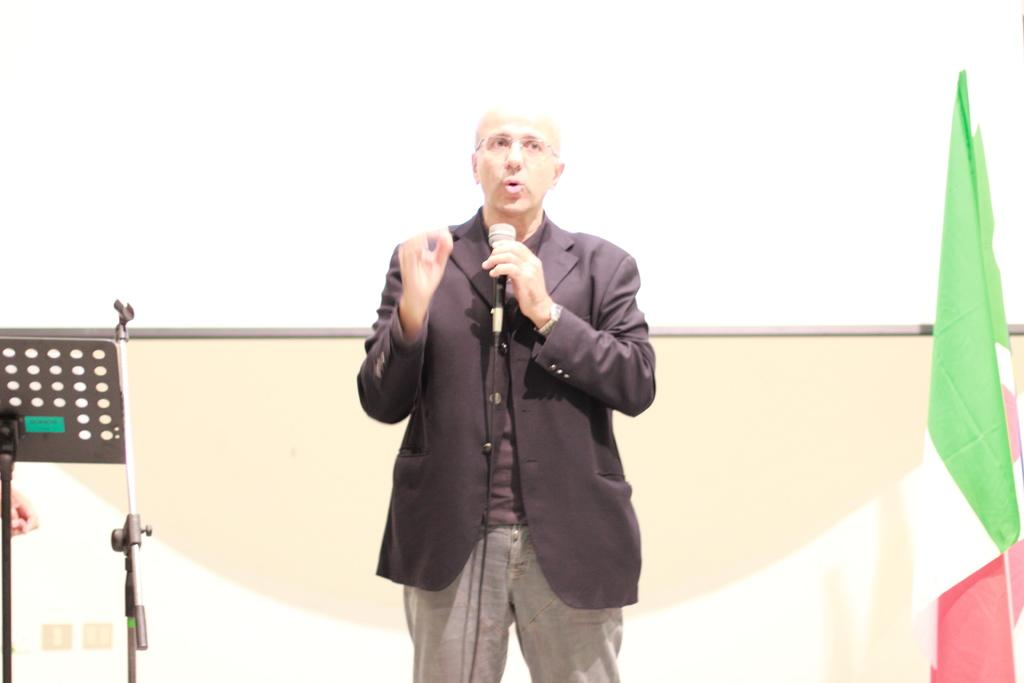Who is the main subject in the image? There is a man in the image. What is the man doing in the image? The man is talking on a mic. What other objects can be seen in the image? There is a flag and a screen in the image. What is the man's suggestion about the amount of chance in the image? There is no mention of a suggestion or chance in the image; it simply shows a man talking on a mic with a flag and a screen present. 